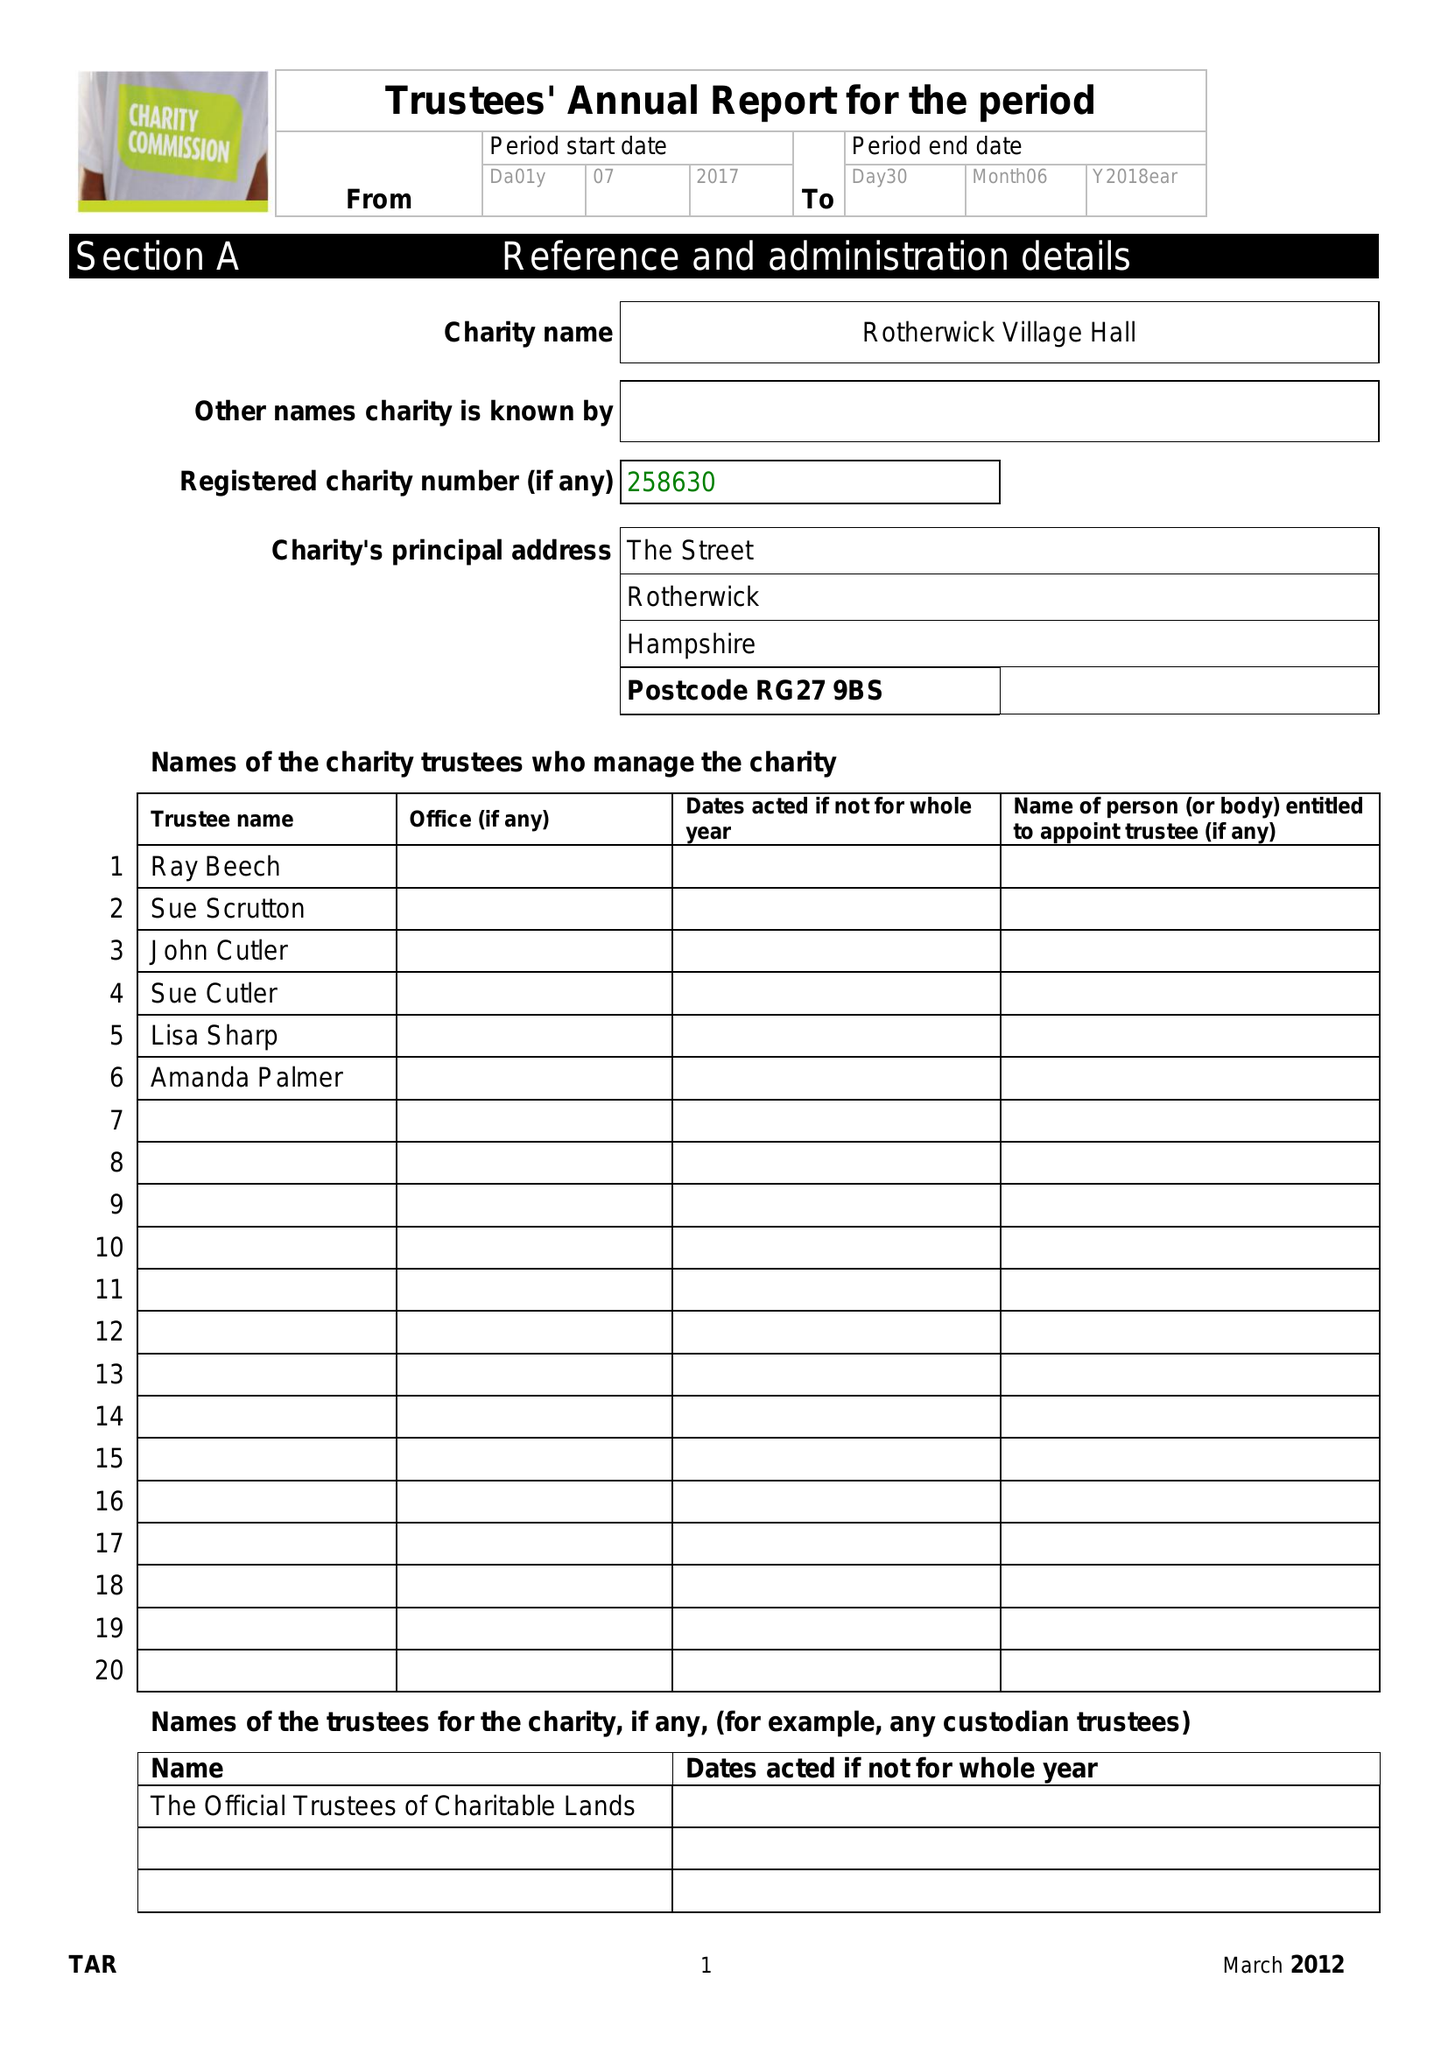What is the value for the spending_annually_in_british_pounds?
Answer the question using a single word or phrase. 33593.00 